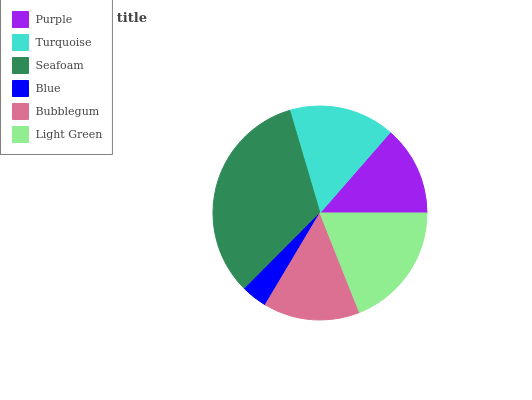Is Blue the minimum?
Answer yes or no. Yes. Is Seafoam the maximum?
Answer yes or no. Yes. Is Turquoise the minimum?
Answer yes or no. No. Is Turquoise the maximum?
Answer yes or no. No. Is Turquoise greater than Purple?
Answer yes or no. Yes. Is Purple less than Turquoise?
Answer yes or no. Yes. Is Purple greater than Turquoise?
Answer yes or no. No. Is Turquoise less than Purple?
Answer yes or no. No. Is Turquoise the high median?
Answer yes or no. Yes. Is Bubblegum the low median?
Answer yes or no. Yes. Is Bubblegum the high median?
Answer yes or no. No. Is Purple the low median?
Answer yes or no. No. 